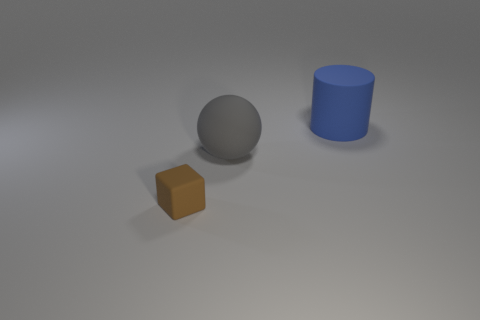Add 2 large cyan cylinders. How many objects exist? 5 Subtract all cylinders. How many objects are left? 2 Subtract all tiny brown blocks. Subtract all cyan matte cubes. How many objects are left? 2 Add 2 brown objects. How many brown objects are left? 3 Add 2 cyan metallic cubes. How many cyan metallic cubes exist? 2 Subtract 0 cyan cylinders. How many objects are left? 3 Subtract all red spheres. Subtract all gray cylinders. How many spheres are left? 1 Subtract all green cylinders. How many red balls are left? 0 